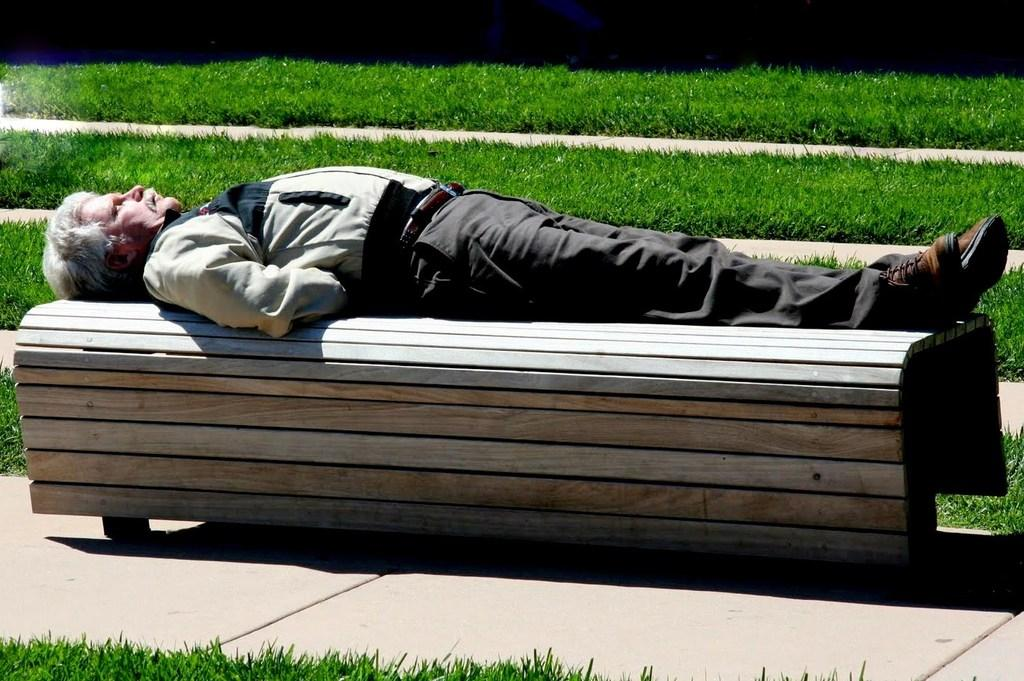What is the man in the image doing? The man is lying on a wooden bench in the image. What is the surface of the ground behind the bench? The ground behind the bench is covered with grass. What type of material is used for the ground in front of the bench? There are stone tiles on the ground in front of the bench. What type of argument is taking place between the man and the grass in the image? There is no argument taking place between the man and the grass in the image. Can you see any wounds on the man in the image? There is no indication of any wounds on the man in the image. 